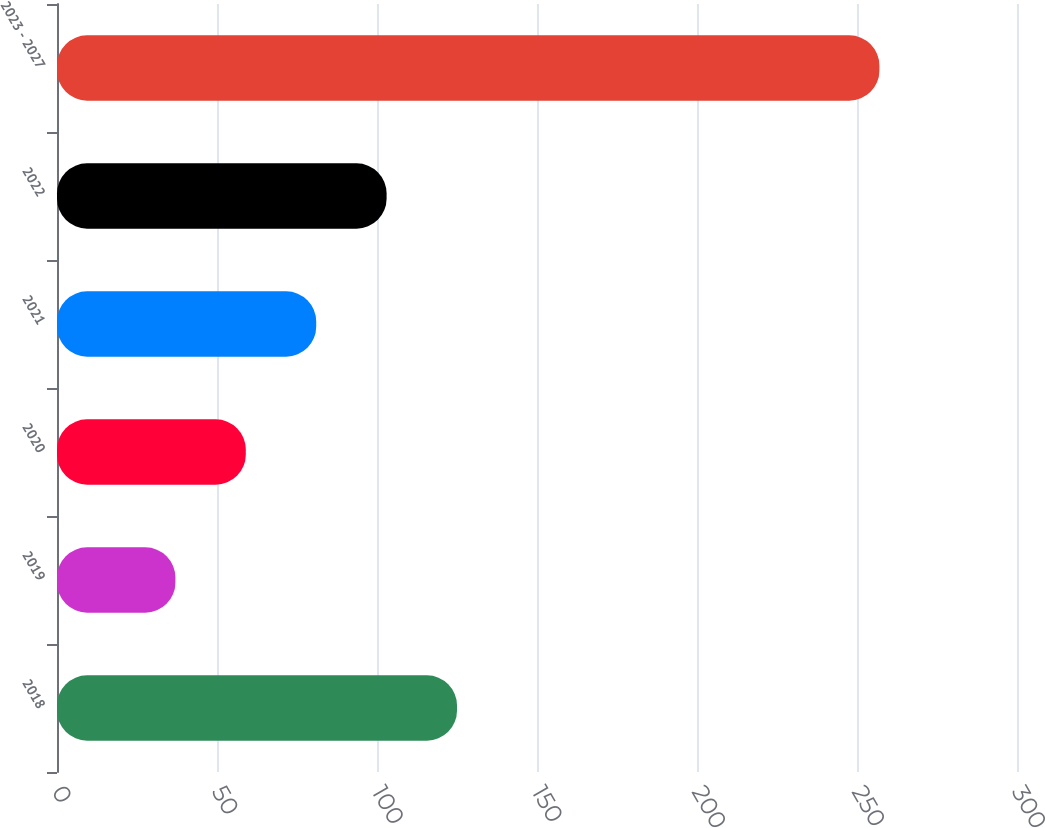<chart> <loc_0><loc_0><loc_500><loc_500><bar_chart><fcel>2018<fcel>2019<fcel>2020<fcel>2021<fcel>2022<fcel>2023 - 2027<nl><fcel>125<fcel>37<fcel>59<fcel>81<fcel>103<fcel>257<nl></chart> 